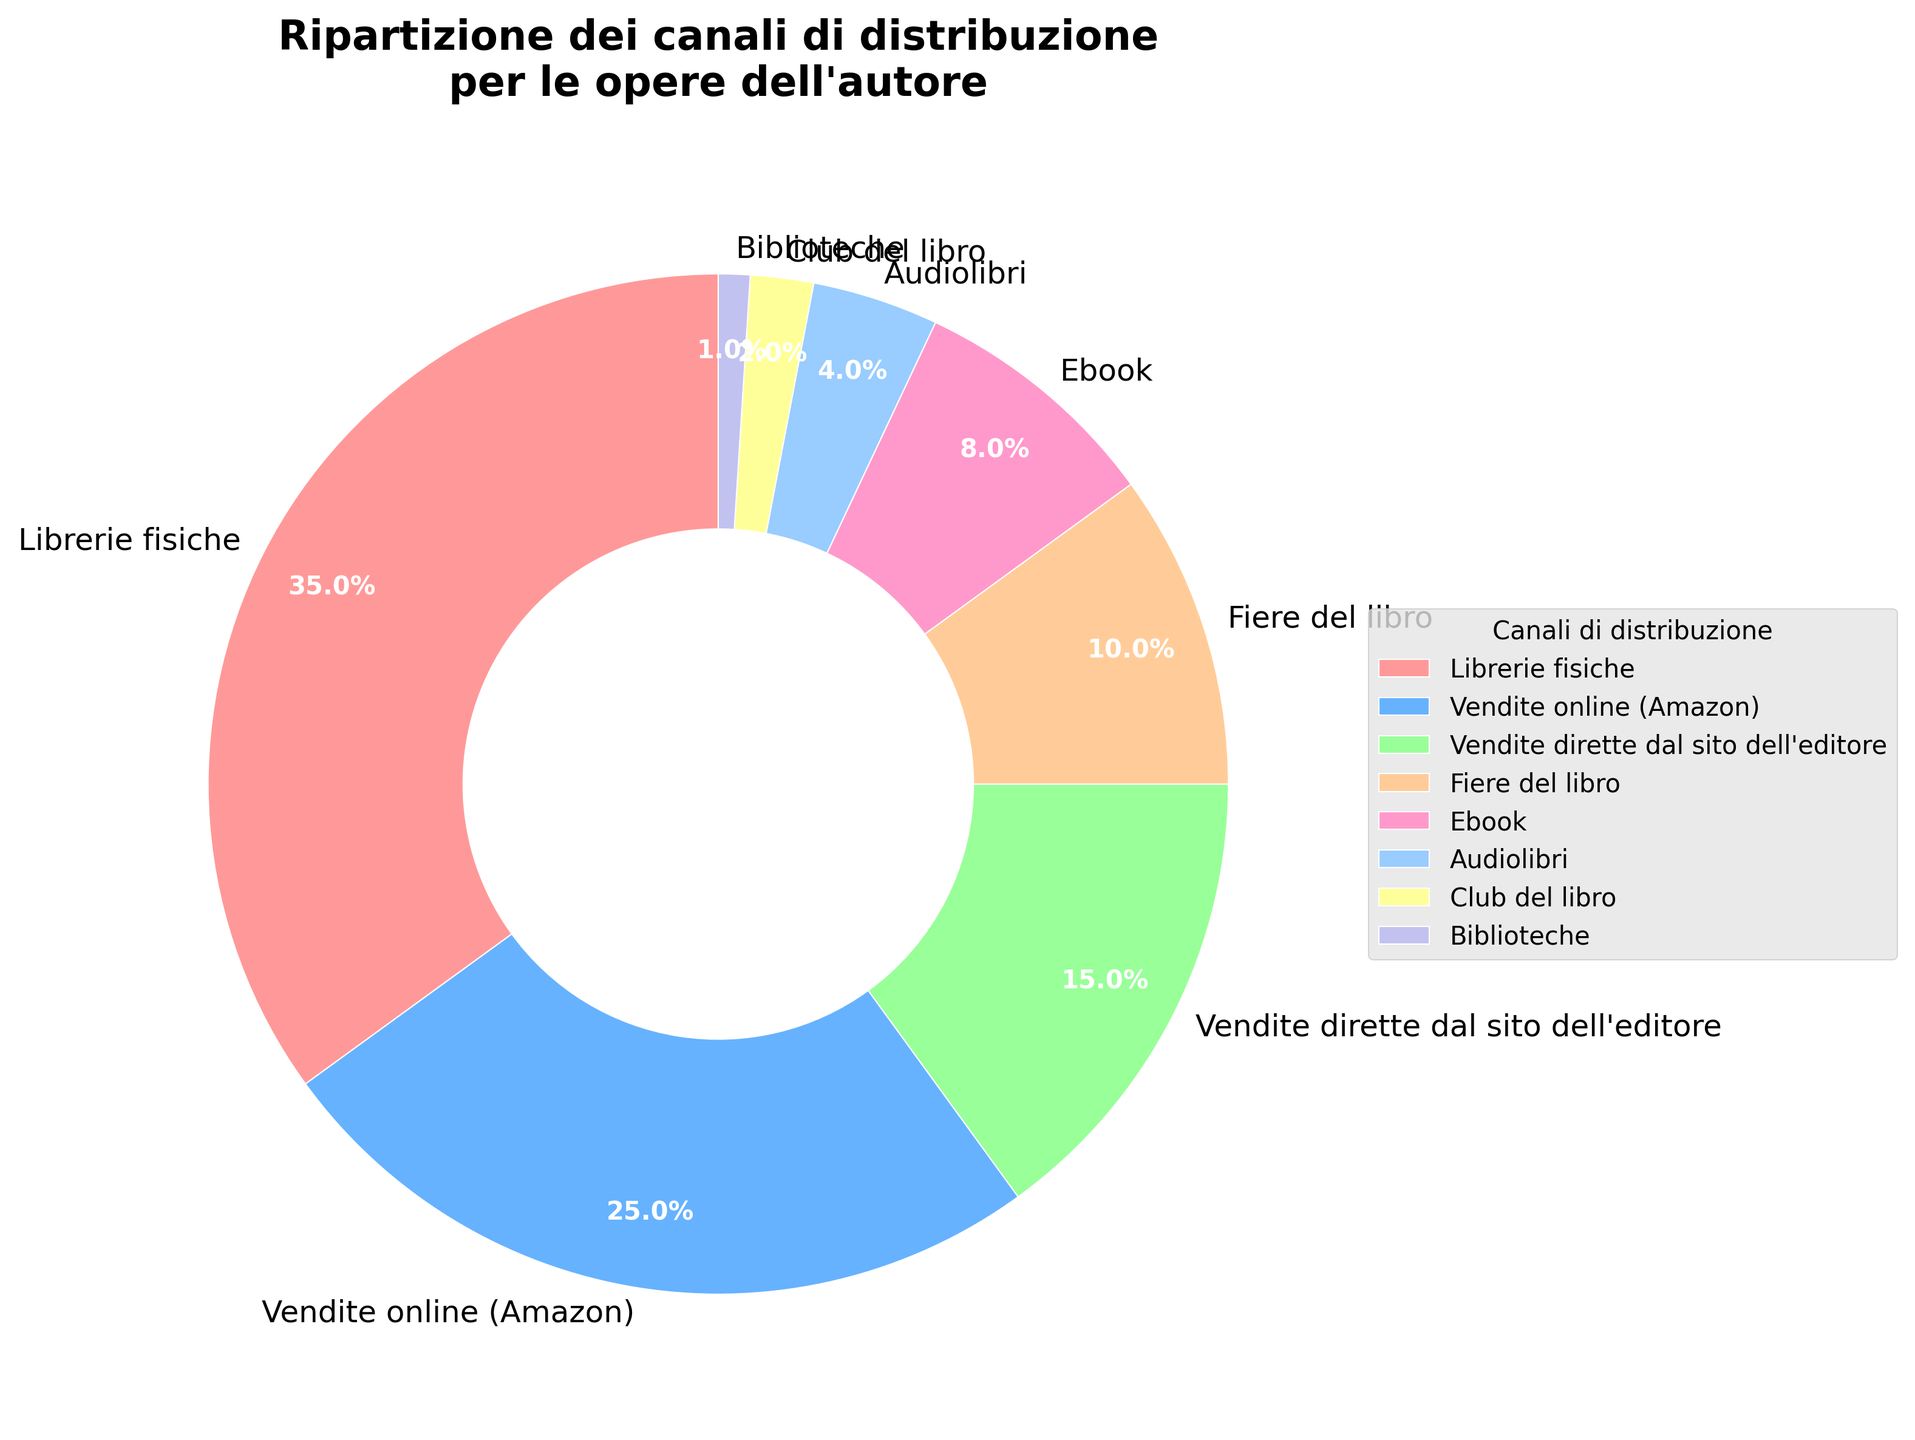What percentage of distribution channels are accounted for by Vendite online (Amazon) and Librerie fisiche combined? To find the combined percentage for Vendite online (Amazon) and Librerie fisiche, add their respective percentages: 25% + 35% = 60%.
Answer: 60% Which distribution channel has the least percentage, and what is it? The distribution channel with the least percentage is Biblioteche, which has a percentage of 1%.
Answer: Biblioteche, 1% What is the combined percentage for the less popular distribution channels (Biblioteche, Club del libro, and Audiolibri)? Add the percentages of Biblioteche (1%), Club del libro (2%), and Audiolibri (4%): 1% + 2% + 4% = 7%.
Answer: 7% How does the percentage of Fiere del libro compare to Vendite dirette dal sito dell'editore? Fiere del libro constitutes 10%, while Vendite dirette dal sito dell'editore constitutes 15%. Therefore, Fiere del libro is 5 percentage points less than Vendite dirette dal sito dell'editore.
Answer: 5 percentage points less What percentage more are Librerie fisiche compared to Ebook? Librerie fisiche have 35%, and Ebook has 8%. To find the percentage more, subtract 8% from 35%: 35% - 8% = 27%.
Answer: 27% Which distribution channel is represented by the green section of the pie chart? The green section of the pie chart represents Ebook, which has a percentage of 8%.
Answer: Ebook What is the total percentage of digital formats (Ebook and Audiolibri)? Add the percentages of Ebook (8%) and Audiolibri (4%): 8% + 4% = 12%.
Answer: 12% Are club del libro and Biblioteche together more popular than Audiolibri? Add the percentages of Club del libro (2%) and Biblioteche (1%): 2% + 1% = 3%. Since Audiolibri has a percentage of 4%, Club del libro and Biblioteche together are less popular than Audiolibri.
Answer: No What distribution channel is 15%, and how is it visually represented? The distribution channel that is 15% is Vendite dirette dal sito dell'editore, and it is represented by a portion of the pie chart (approx. one-sixth of the chart).
Answer: Vendite dirette dal sito dell'editore 